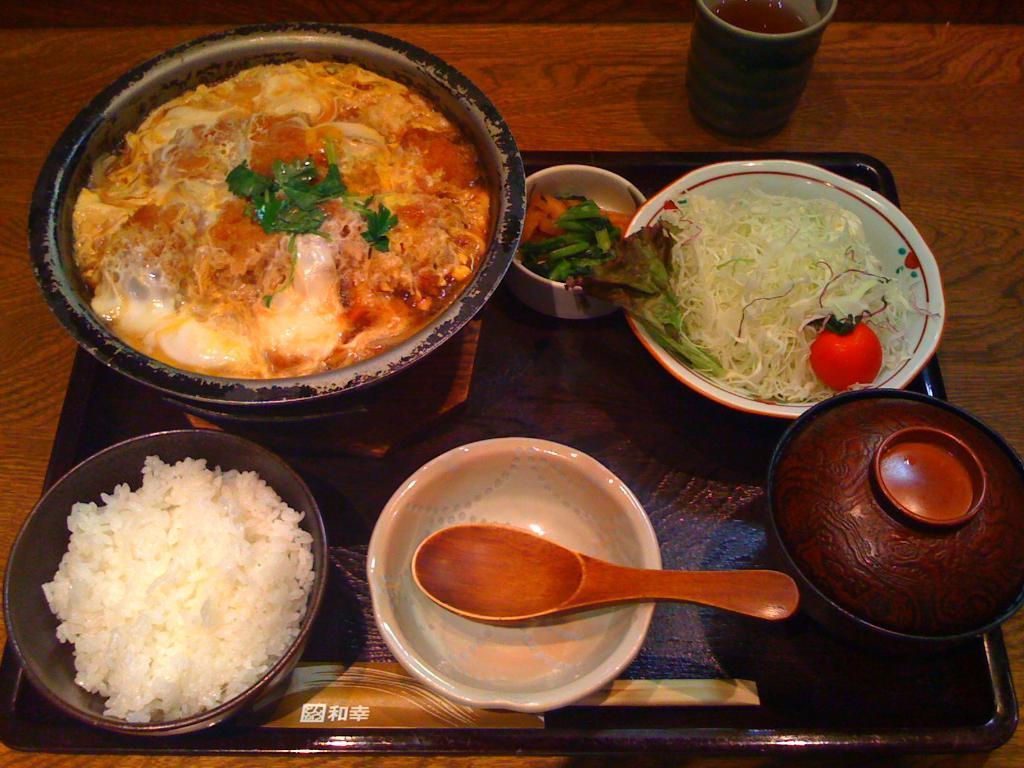In one or two sentences, can you explain what this image depicts? In the picture we can see the wooden table on it, we can see some food items in the bowls and we can also see an empty bowl with a spoon in it and beside it we can see the glass with a drink. 